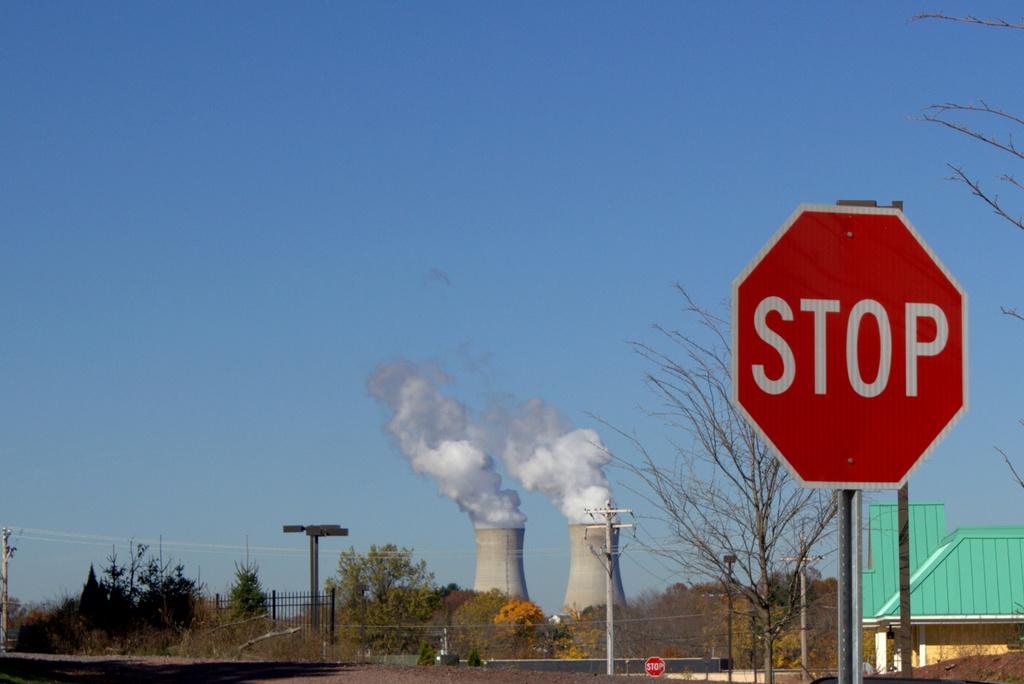Provide a one-sentence caption for the provided image. The cooling towers of the nuclear power plant loomed over the town. 